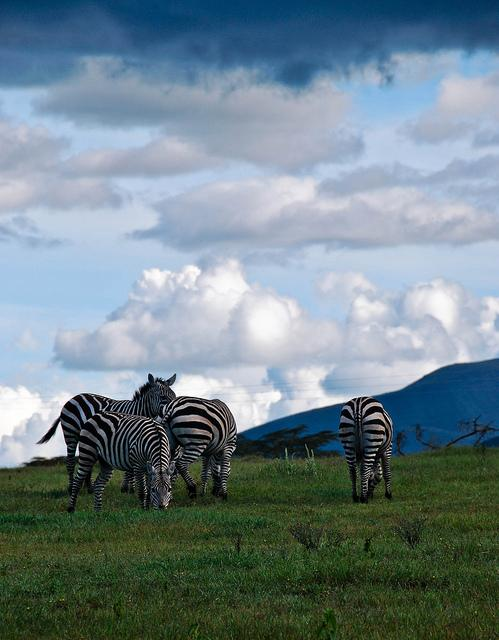How many zebras are grazing in the field before the mountain?

Choices:
A) three
B) four
C) two
D) five four 